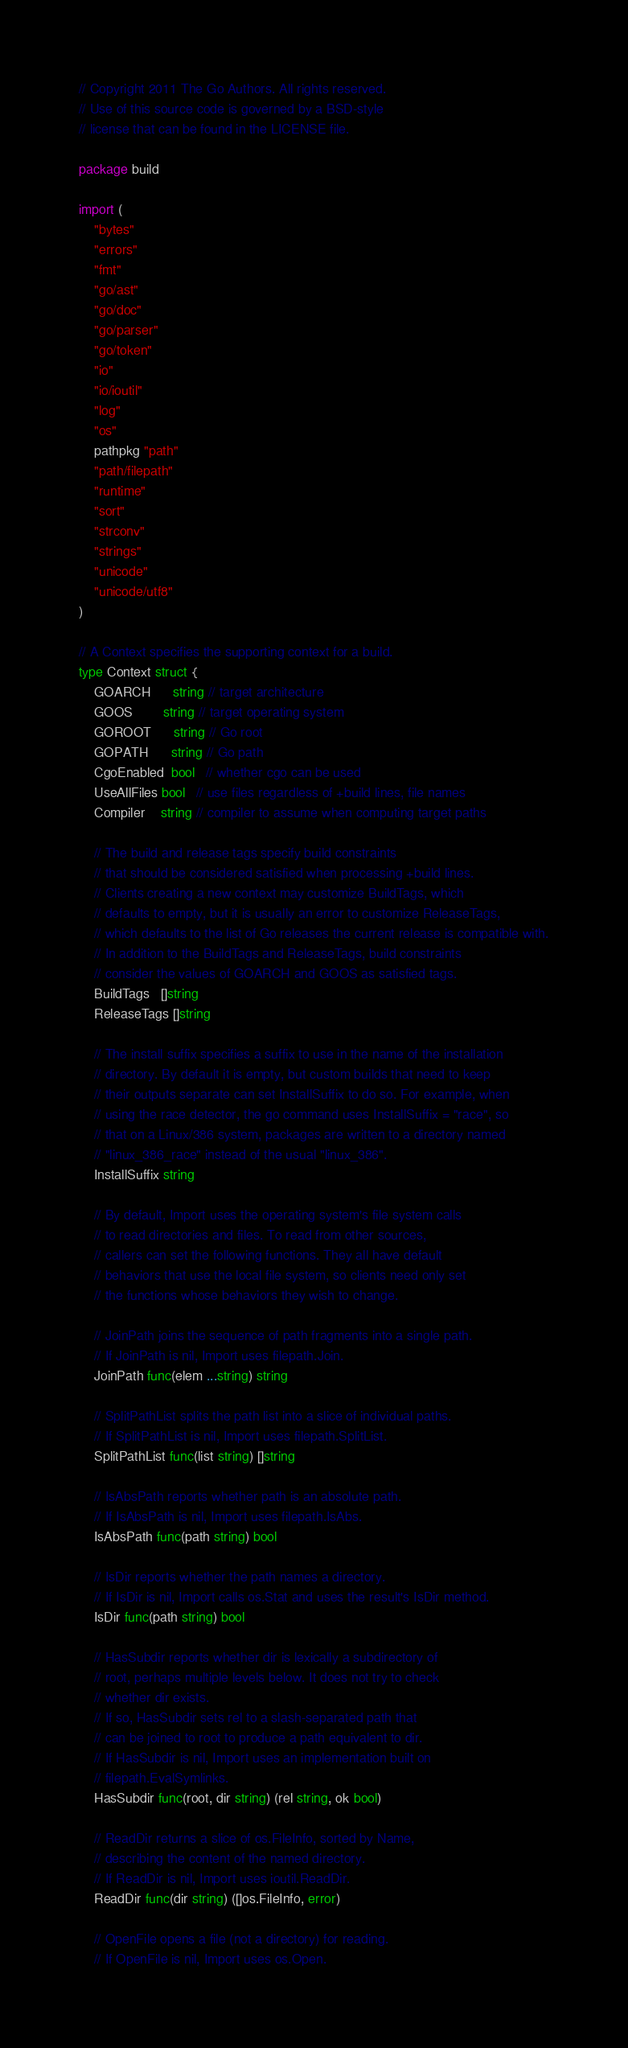<code> <loc_0><loc_0><loc_500><loc_500><_Go_>// Copyright 2011 The Go Authors. All rights reserved.
// Use of this source code is governed by a BSD-style
// license that can be found in the LICENSE file.

package build

import (
	"bytes"
	"errors"
	"fmt"
	"go/ast"
	"go/doc"
	"go/parser"
	"go/token"
	"io"
	"io/ioutil"
	"log"
	"os"
	pathpkg "path"
	"path/filepath"
	"runtime"
	"sort"
	"strconv"
	"strings"
	"unicode"
	"unicode/utf8"
)

// A Context specifies the supporting context for a build.
type Context struct {
	GOARCH      string // target architecture
	GOOS        string // target operating system
	GOROOT      string // Go root
	GOPATH      string // Go path
	CgoEnabled  bool   // whether cgo can be used
	UseAllFiles bool   // use files regardless of +build lines, file names
	Compiler    string // compiler to assume when computing target paths

	// The build and release tags specify build constraints
	// that should be considered satisfied when processing +build lines.
	// Clients creating a new context may customize BuildTags, which
	// defaults to empty, but it is usually an error to customize ReleaseTags,
	// which defaults to the list of Go releases the current release is compatible with.
	// In addition to the BuildTags and ReleaseTags, build constraints
	// consider the values of GOARCH and GOOS as satisfied tags.
	BuildTags   []string
	ReleaseTags []string

	// The install suffix specifies a suffix to use in the name of the installation
	// directory. By default it is empty, but custom builds that need to keep
	// their outputs separate can set InstallSuffix to do so. For example, when
	// using the race detector, the go command uses InstallSuffix = "race", so
	// that on a Linux/386 system, packages are written to a directory named
	// "linux_386_race" instead of the usual "linux_386".
	InstallSuffix string

	// By default, Import uses the operating system's file system calls
	// to read directories and files. To read from other sources,
	// callers can set the following functions. They all have default
	// behaviors that use the local file system, so clients need only set
	// the functions whose behaviors they wish to change.

	// JoinPath joins the sequence of path fragments into a single path.
	// If JoinPath is nil, Import uses filepath.Join.
	JoinPath func(elem ...string) string

	// SplitPathList splits the path list into a slice of individual paths.
	// If SplitPathList is nil, Import uses filepath.SplitList.
	SplitPathList func(list string) []string

	// IsAbsPath reports whether path is an absolute path.
	// If IsAbsPath is nil, Import uses filepath.IsAbs.
	IsAbsPath func(path string) bool

	// IsDir reports whether the path names a directory.
	// If IsDir is nil, Import calls os.Stat and uses the result's IsDir method.
	IsDir func(path string) bool

	// HasSubdir reports whether dir is lexically a subdirectory of
	// root, perhaps multiple levels below. It does not try to check
	// whether dir exists.
	// If so, HasSubdir sets rel to a slash-separated path that
	// can be joined to root to produce a path equivalent to dir.
	// If HasSubdir is nil, Import uses an implementation built on
	// filepath.EvalSymlinks.
	HasSubdir func(root, dir string) (rel string, ok bool)

	// ReadDir returns a slice of os.FileInfo, sorted by Name,
	// describing the content of the named directory.
	// If ReadDir is nil, Import uses ioutil.ReadDir.
	ReadDir func(dir string) ([]os.FileInfo, error)

	// OpenFile opens a file (not a directory) for reading.
	// If OpenFile is nil, Import uses os.Open.</code> 